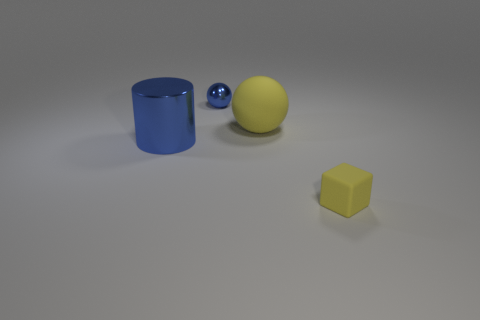Add 4 large gray rubber cylinders. How many objects exist? 8 Subtract all cubes. How many objects are left? 3 Subtract all big cyan things. Subtract all tiny blocks. How many objects are left? 3 Add 4 large matte spheres. How many large matte spheres are left? 5 Add 3 balls. How many balls exist? 5 Subtract 0 gray cylinders. How many objects are left? 4 